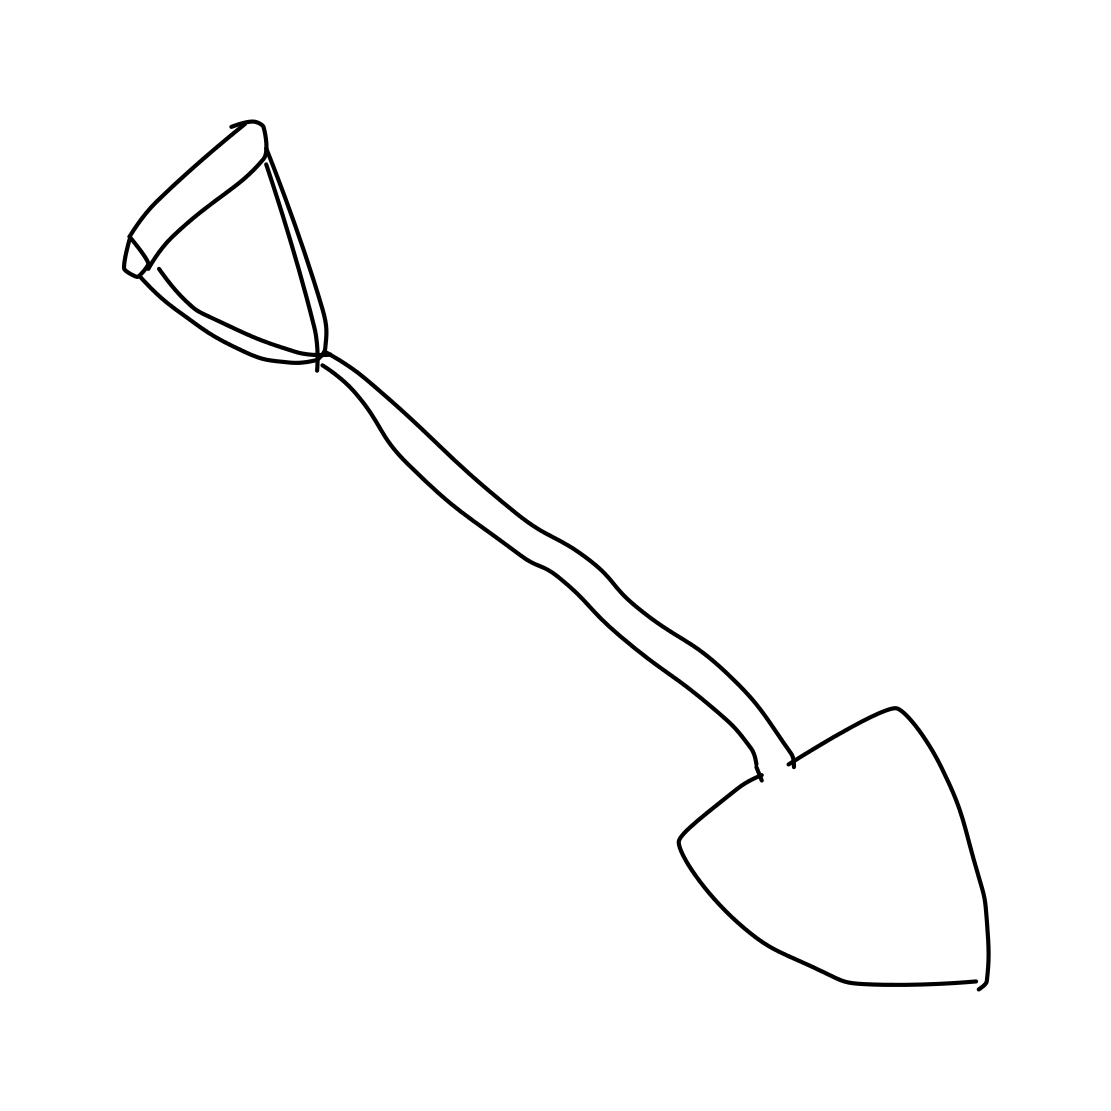Does the style of the sketch suggest a professional or amateur artist? The style of the sketch, with its simple and clean lines, could suggest an amateur artist or someone creating a quick conceptual representation. It lacks intricate detailing or shading that might characterize the work of a professional artist focusing on realism. 